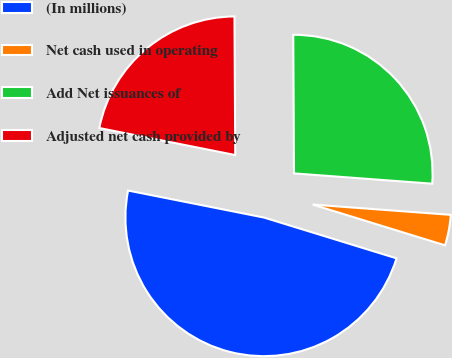Convert chart. <chart><loc_0><loc_0><loc_500><loc_500><pie_chart><fcel>(In millions)<fcel>Net cash used in operating<fcel>Add Net issuances of<fcel>Adjusted net cash provided by<nl><fcel>48.37%<fcel>3.57%<fcel>26.27%<fcel>21.79%<nl></chart> 